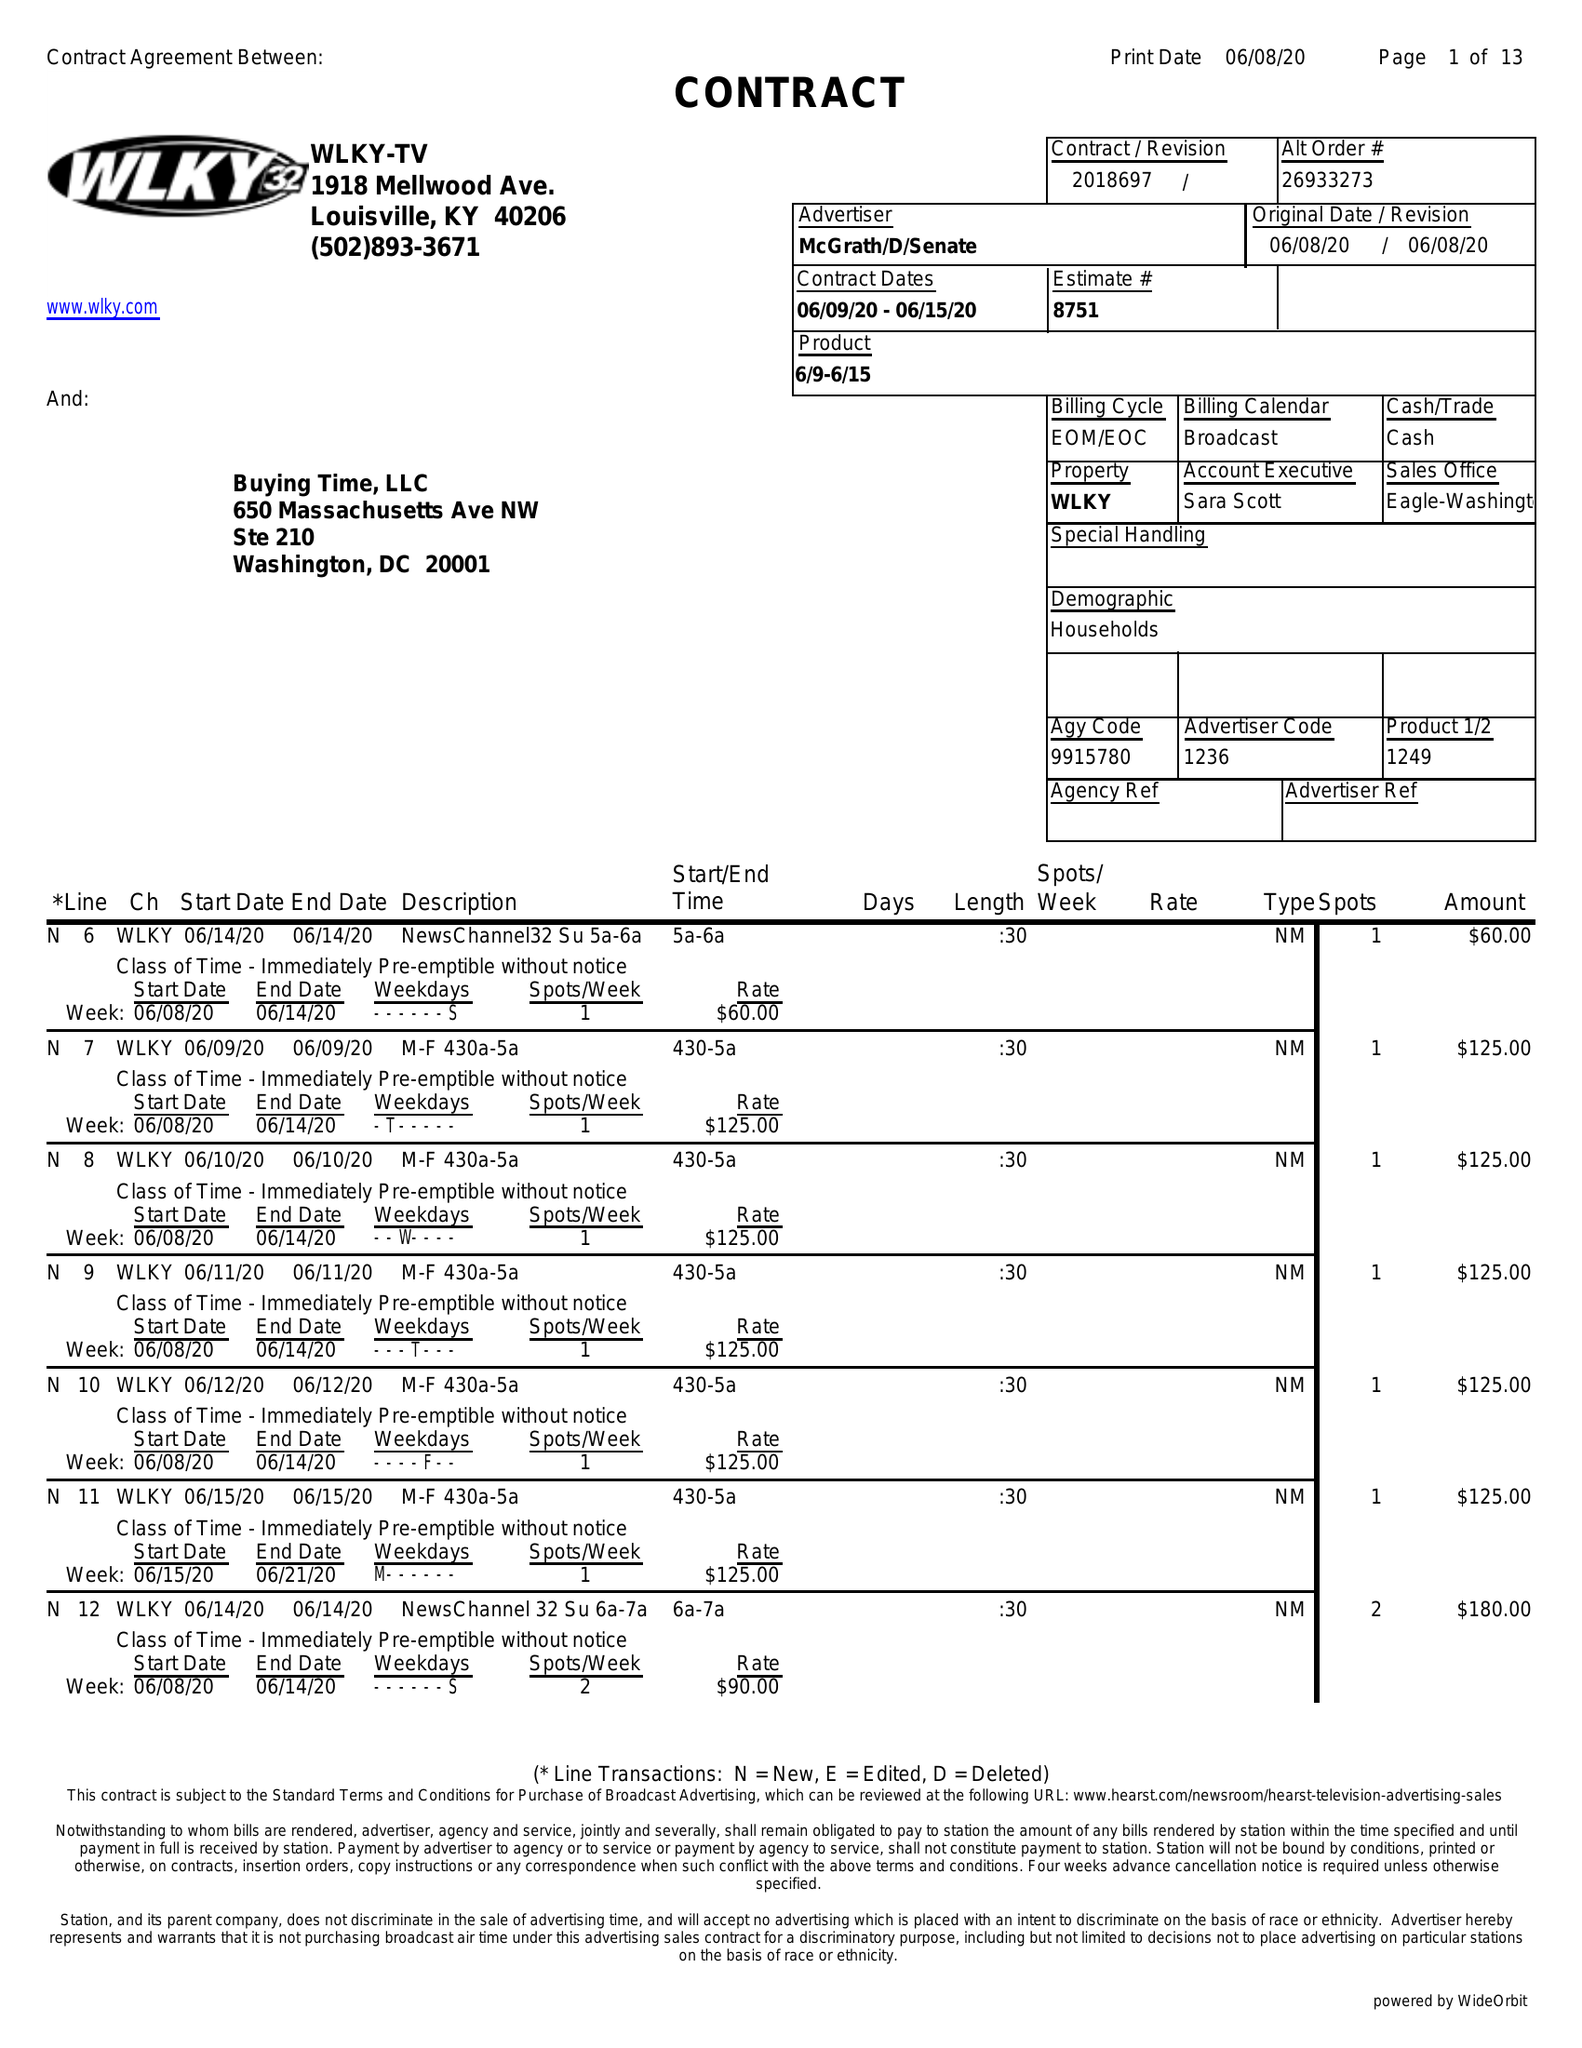What is the value for the advertiser?
Answer the question using a single word or phrase. MCGRATH/D/SENATE 